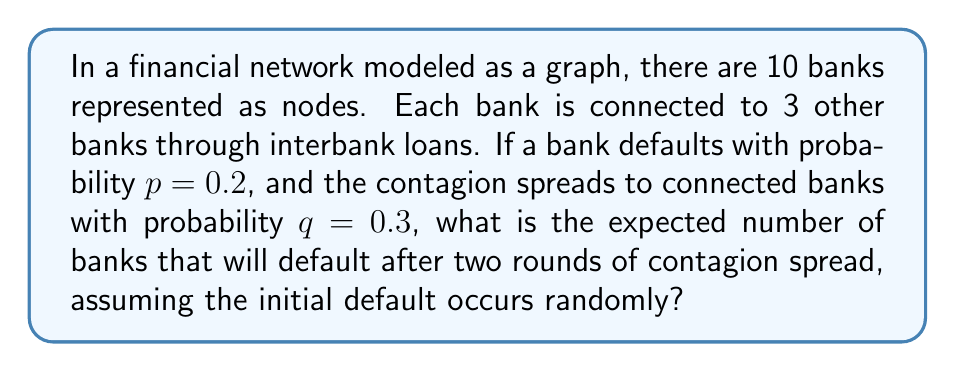Help me with this question. Let's approach this step-by-step using concepts from graph theory and epidemic models:

1) First, we need to calculate the probability of a bank defaulting in the first round:
   $P(\text{default in round 1}) = p = 0.2$

2) For the second round, a bank will default if it's connected to a defaulted bank (probability 3/9, as each bank is connected to 3 out of the other 9 banks) and the contagion spreads (probability q). So:
   $P(\text{default in round 2} | \text{not defaulted in round 1}) = \frac{3}{9} \cdot q \cdot p = \frac{1}{3} \cdot 0.3 \cdot 0.2 = 0.02$

3) The probability of a bank defaulting by the end of round 2 is:
   $P(\text{default by end of round 2}) = p + (1-p) \cdot \frac{1}{3} \cdot q \cdot p$
   $= 0.2 + 0.8 \cdot 0.02 = 0.216$

4) The expected number of defaulted banks is the total number of banks multiplied by this probability:
   $E(\text{defaulted banks}) = 10 \cdot 0.216 = 2.16$

This result aligns with the intuition that financial contagion can amplify the initial shock, as the expected number of defaults (2.16) is higher than what we would expect from the initial default probability alone (10 * 0.2 = 2).
Answer: The expected number of banks that will default after two rounds of contagion spread is 2.16. 